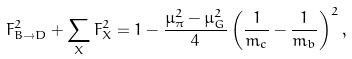Convert formula to latex. <formula><loc_0><loc_0><loc_500><loc_500>F _ { B \to D } ^ { 2 } + \sum _ { X } F _ { X } ^ { 2 } = 1 - \frac { \mu _ { \pi } ^ { 2 } - \mu _ { G } ^ { 2 } } { 4 } \left ( \frac { 1 } { m _ { c } } - \frac { 1 } { m _ { b } } \right ) ^ { 2 } ,</formula> 